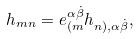<formula> <loc_0><loc_0><loc_500><loc_500>h _ { m n } = e _ { ( m } ^ { \alpha { \dot { \beta } } } h _ { n ) , \alpha { \dot { \beta } } } ,</formula> 